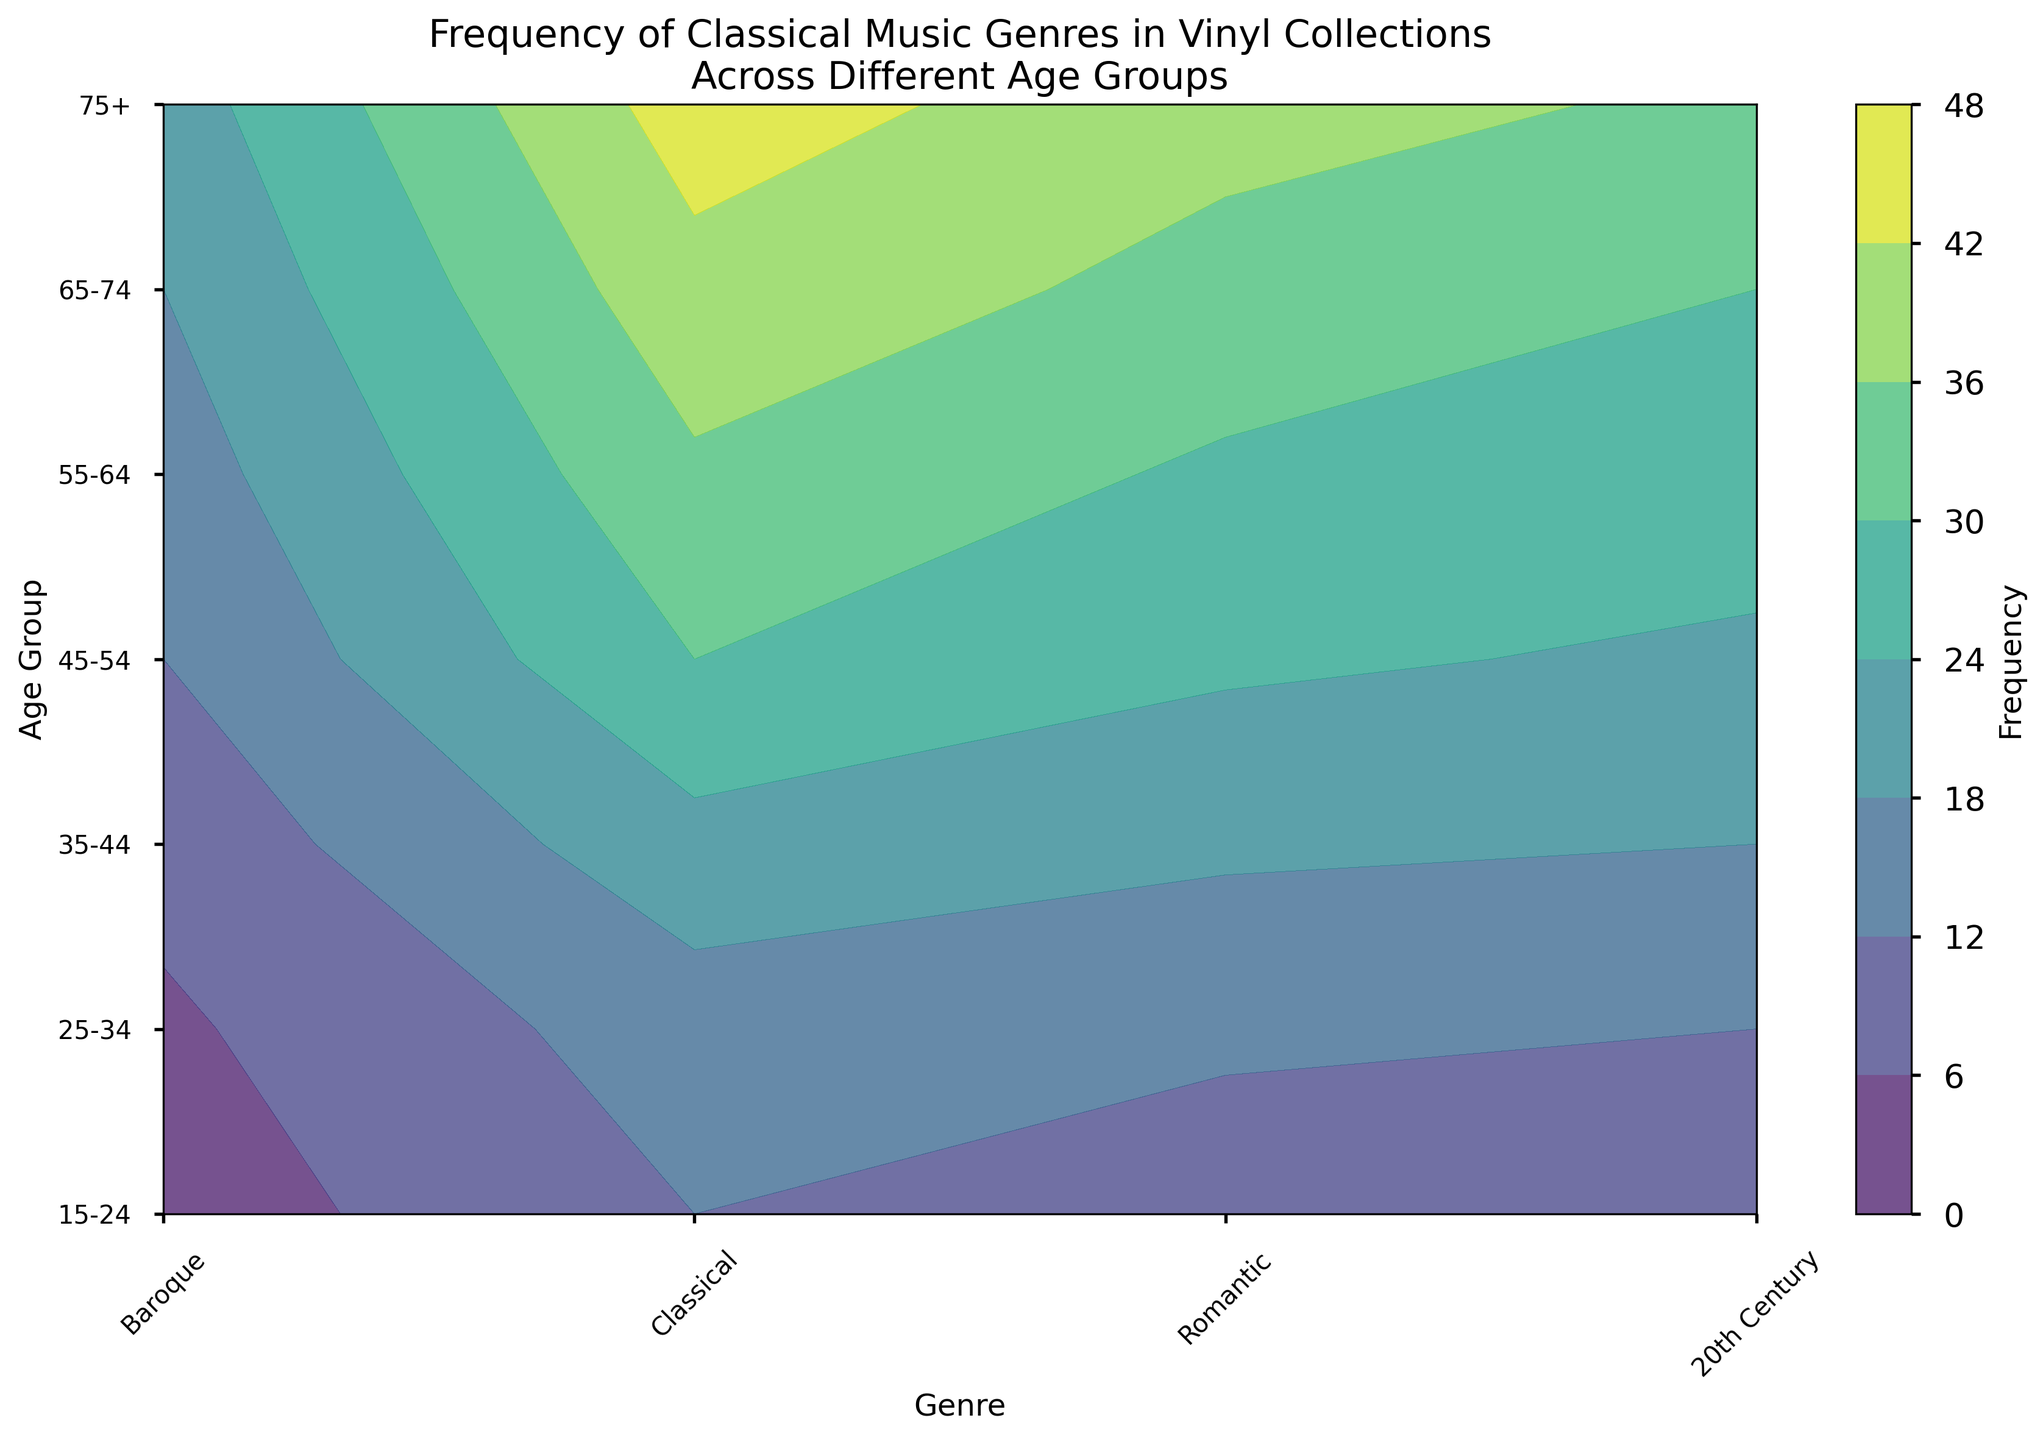Which age group has the highest frequency of Romantic vinyl records? By examining the y-axis labels for age groups and the contour color intensity for the Romantic genre column, we can see that the darkest color, indicating the highest frequency, corresponds to the 75+ age group.
Answer: 75+ What is the average frequency of 20th Century music across all age groups? Add the frequencies of 20th Century music for all age groups and then divide by the number of age groups: (3 + 5 + 8 + 12 + 15 + 18 + 21) / 7 = 11.71.
Answer: 11.71 Which genre has the least frequency among the 15-24 age group? By looking at the x-axis for each genre in the 15-24 age group, we see that 20th Century has the lightest color, indicating the least frequency (3).
Answer: 20th Century Compare the frequency of Baroque records between the 35-44 and 45-54 age groups. Which is greater, and by how much? Baroque frequencies for 35-44 and 45-54 are 22 and 30 respectively. The difference is 30 - 22 = 8.
Answer: 45-54; 8 How does the frequency of Classical music change from the 25-34 age group to the 55-64 age group? Classical music frequency in the 25-34 age group is 13, and in the 55-64 age group is 29. The change is 29 - 13 = 16.
Answer: Increases by 16 Which genre has the most consistent frequency across all age groups? By visually examining the contour plot, we see that Baroque has the least change in color intensity across all age groups.
Answer: Baroque What is the total frequency of all genres for the 65-74 age group? Sum the frequencies of all genres for the 65-74 age group: 40 (Baroque) + 34 (Classical) + 30 (Romantic) + 18 (20th Century) = 122.
Answer: 122 